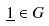<formula> <loc_0><loc_0><loc_500><loc_500>\underline { 1 } \in G</formula> 